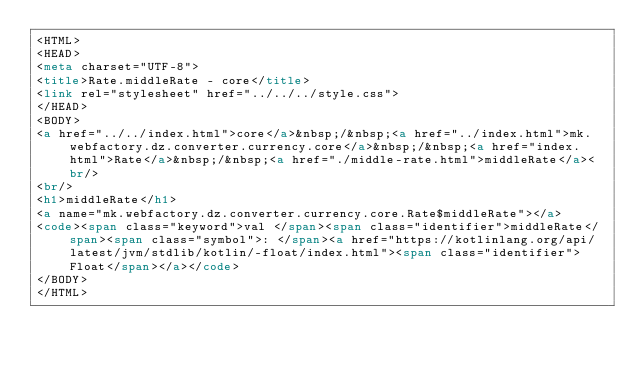Convert code to text. <code><loc_0><loc_0><loc_500><loc_500><_HTML_><HTML>
<HEAD>
<meta charset="UTF-8">
<title>Rate.middleRate - core</title>
<link rel="stylesheet" href="../../../style.css">
</HEAD>
<BODY>
<a href="../../index.html">core</a>&nbsp;/&nbsp;<a href="../index.html">mk.webfactory.dz.converter.currency.core</a>&nbsp;/&nbsp;<a href="index.html">Rate</a>&nbsp;/&nbsp;<a href="./middle-rate.html">middleRate</a><br/>
<br/>
<h1>middleRate</h1>
<a name="mk.webfactory.dz.converter.currency.core.Rate$middleRate"></a>
<code><span class="keyword">val </span><span class="identifier">middleRate</span><span class="symbol">: </span><a href="https://kotlinlang.org/api/latest/jvm/stdlib/kotlin/-float/index.html"><span class="identifier">Float</span></a></code>
</BODY>
</HTML>
</code> 